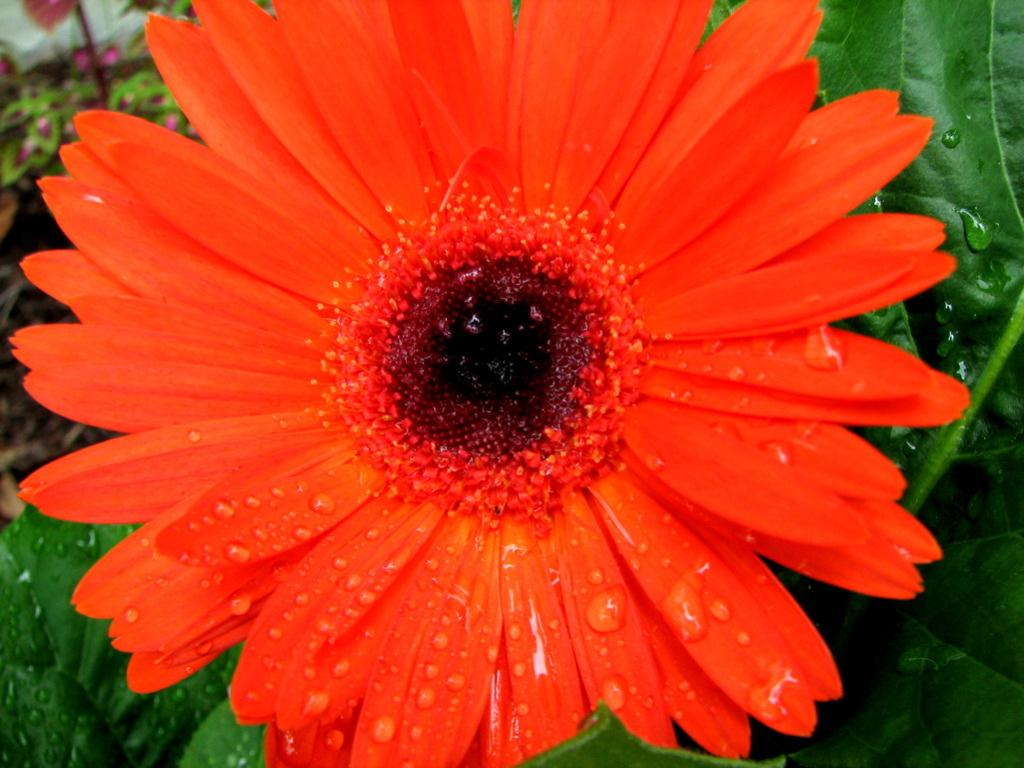What type of flower is in the image? There is a red color sunflower in the image. What else can be seen in the image besides the sunflower? There are leaves in the image. What class is the sunflower attending in the image? The sunflower is not attending a class, as it is a plant and not a sentient being. 